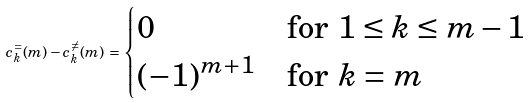<formula> <loc_0><loc_0><loc_500><loc_500>c ^ { = } _ { k } ( m ) - c ^ { \neq } _ { k } ( m ) \, = \, \begin{cases} 0 & \text {for $1 \leq k \leq m-1$} \\ ( - 1 ) ^ { m + 1 } & \text {for $k=m$} \end{cases}</formula> 